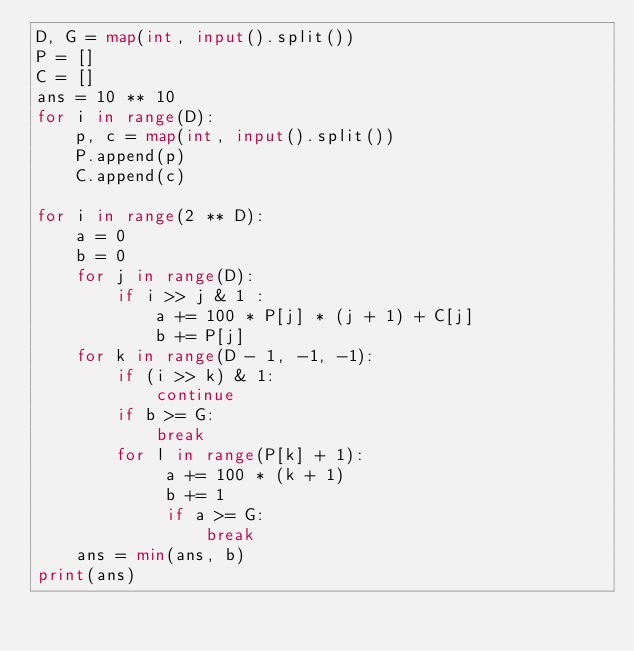Convert code to text. <code><loc_0><loc_0><loc_500><loc_500><_Python_>D, G = map(int, input().split())
P = []
C = []
ans = 10 ** 10
for i in range(D):
    p, c = map(int, input().split())
    P.append(p)
    C.append(c)

for i in range(2 ** D):
    a = 0
    b = 0
    for j in range(D):
        if i >> j & 1 :
            a += 100 * P[j] * (j + 1) + C[j]
            b += P[j]
    for k in range(D - 1, -1, -1):
        if (i >> k) & 1:
            continue
        if b >= G:
            break
        for l in range(P[k] + 1):
             a += 100 * (k + 1)
             b += 1
             if a >= G:
                 break
    ans = min(ans, b)
print(ans)</code> 